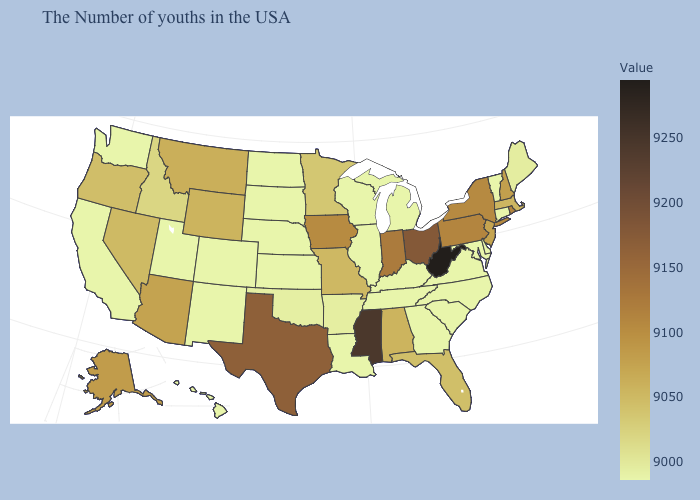Is the legend a continuous bar?
Concise answer only. Yes. Is the legend a continuous bar?
Concise answer only. Yes. 